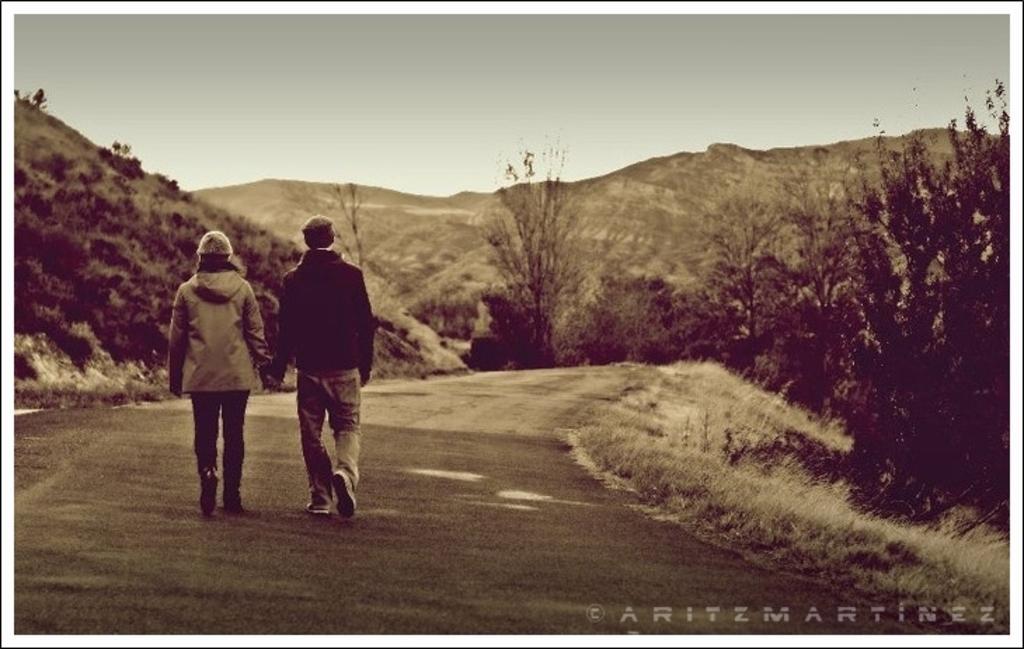Please provide a concise description of this image. This is black and white image. There are a few people, trees, plants, hills. We can see the ground with some grass. We can also see some text on the bottom right corner. 